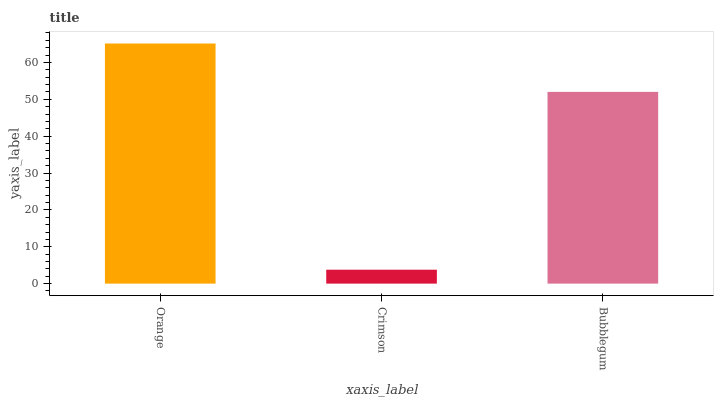Is Crimson the minimum?
Answer yes or no. Yes. Is Orange the maximum?
Answer yes or no. Yes. Is Bubblegum the minimum?
Answer yes or no. No. Is Bubblegum the maximum?
Answer yes or no. No. Is Bubblegum greater than Crimson?
Answer yes or no. Yes. Is Crimson less than Bubblegum?
Answer yes or no. Yes. Is Crimson greater than Bubblegum?
Answer yes or no. No. Is Bubblegum less than Crimson?
Answer yes or no. No. Is Bubblegum the high median?
Answer yes or no. Yes. Is Bubblegum the low median?
Answer yes or no. Yes. Is Orange the high median?
Answer yes or no. No. Is Orange the low median?
Answer yes or no. No. 